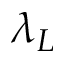<formula> <loc_0><loc_0><loc_500><loc_500>\lambda _ { L }</formula> 